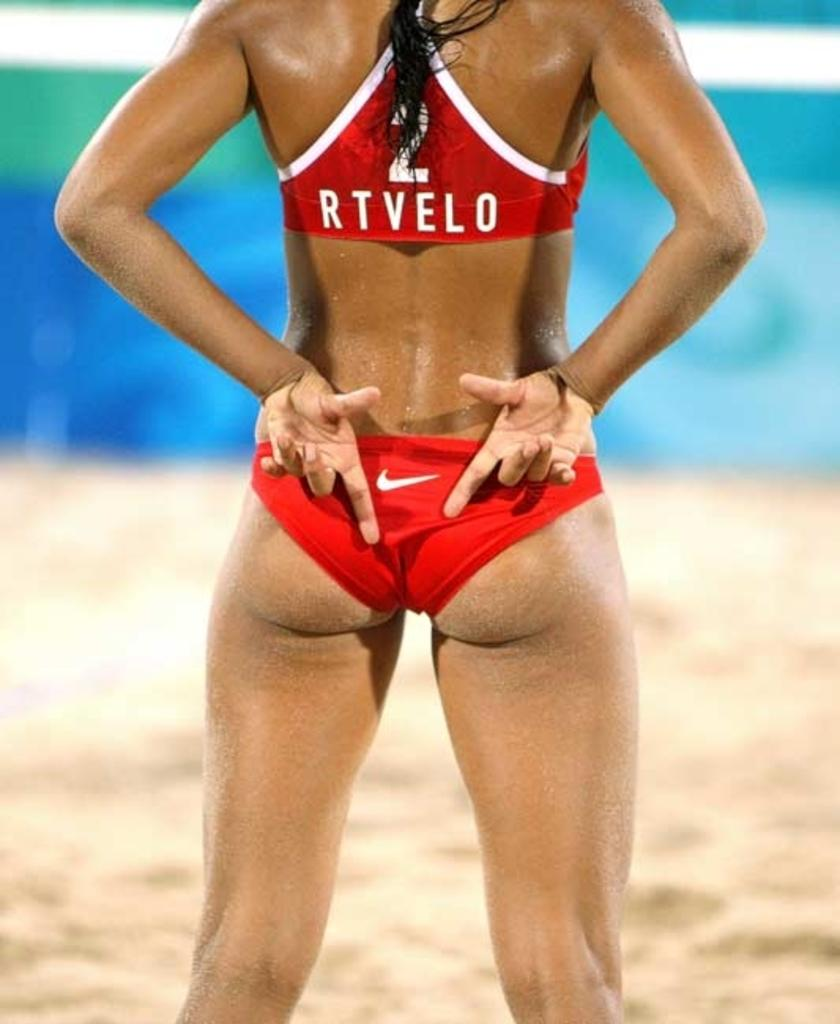<image>
Provide a brief description of the given image. A volley ball player has her hands behind her back and her top says 2 RTVELO. 